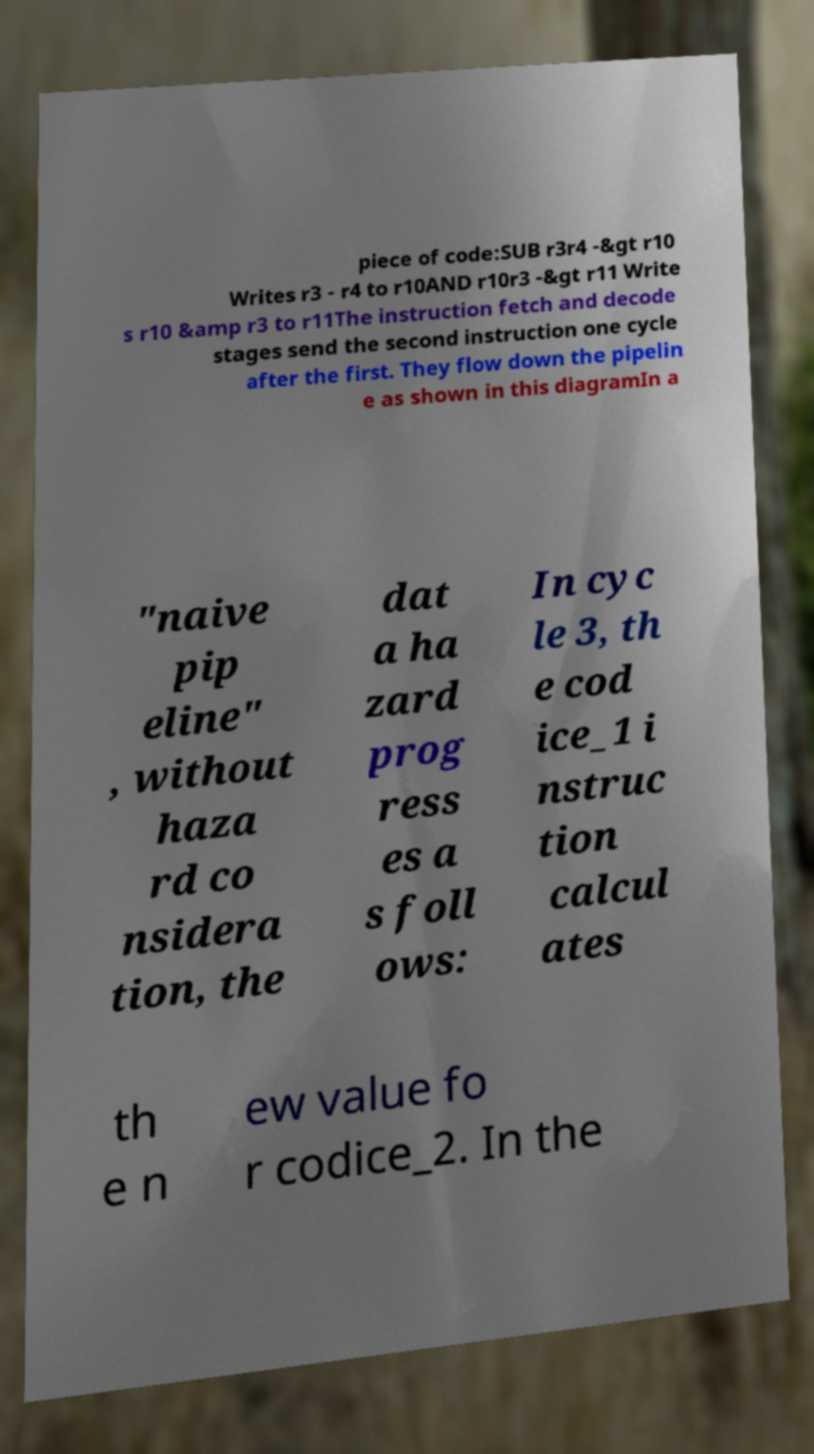Can you read and provide the text displayed in the image?This photo seems to have some interesting text. Can you extract and type it out for me? piece of code:SUB r3r4 -&gt r10 Writes r3 - r4 to r10AND r10r3 -&gt r11 Write s r10 &amp r3 to r11The instruction fetch and decode stages send the second instruction one cycle after the first. They flow down the pipelin e as shown in this diagramIn a "naive pip eline" , without haza rd co nsidera tion, the dat a ha zard prog ress es a s foll ows: In cyc le 3, th e cod ice_1 i nstruc tion calcul ates th e n ew value fo r codice_2. In the 